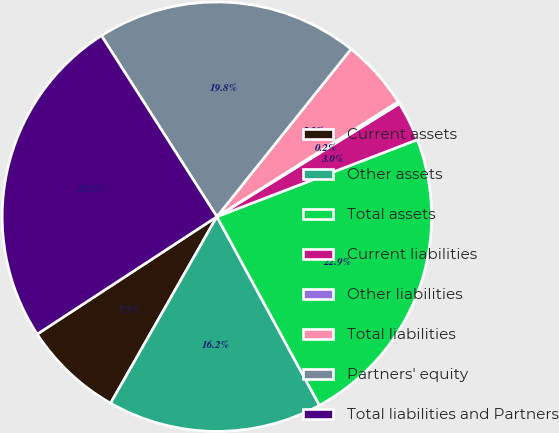Convert chart. <chart><loc_0><loc_0><loc_500><loc_500><pie_chart><fcel>Current assets<fcel>Other assets<fcel>Total assets<fcel>Current liabilities<fcel>Other liabilities<fcel>Total liabilities<fcel>Partners' equity<fcel>Total liabilities and Partners<nl><fcel>7.54%<fcel>16.17%<fcel>22.91%<fcel>2.99%<fcel>0.17%<fcel>5.26%<fcel>19.78%<fcel>25.18%<nl></chart> 